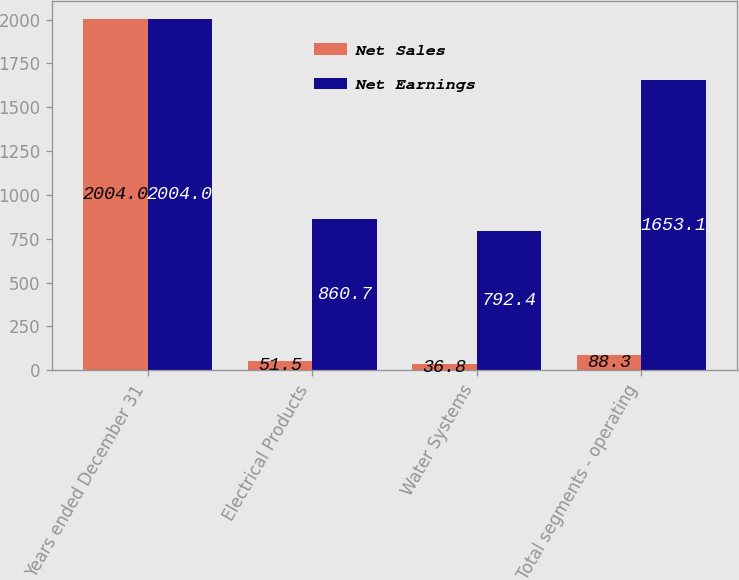Convert chart to OTSL. <chart><loc_0><loc_0><loc_500><loc_500><stacked_bar_chart><ecel><fcel>Years ended December 31<fcel>Electrical Products<fcel>Water Systems<fcel>Total segments - operating<nl><fcel>Net Sales<fcel>2004<fcel>51.5<fcel>36.8<fcel>88.3<nl><fcel>Net Earnings<fcel>2004<fcel>860.7<fcel>792.4<fcel>1653.1<nl></chart> 